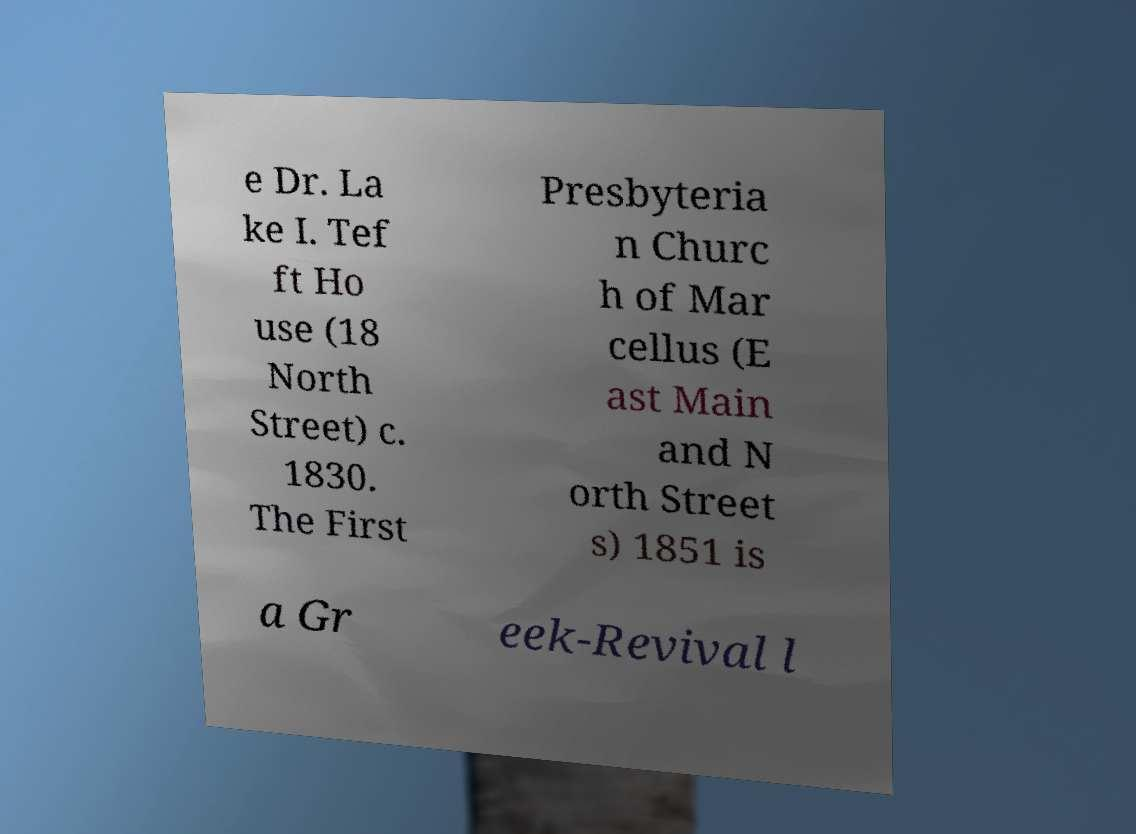Could you assist in decoding the text presented in this image and type it out clearly? e Dr. La ke I. Tef ft Ho use (18 North Street) c. 1830. The First Presbyteria n Churc h of Mar cellus (E ast Main and N orth Street s) 1851 is a Gr eek-Revival l 